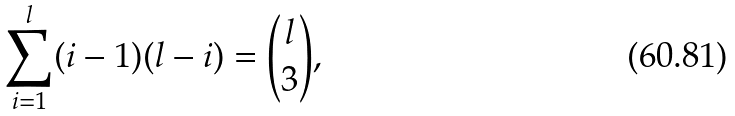Convert formula to latex. <formula><loc_0><loc_0><loc_500><loc_500>\sum _ { i = 1 } ^ { l } ( i - 1 ) ( l - i ) = \binom { l } { 3 } ,</formula> 